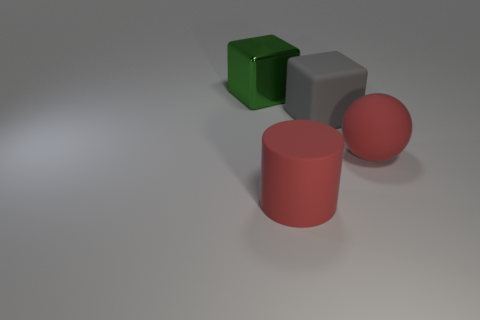Add 2 rubber balls. How many objects exist? 6 Add 2 red objects. How many red objects exist? 4 Subtract 0 yellow cylinders. How many objects are left? 4 Subtract all cylinders. How many objects are left? 3 Subtract all gray cubes. Subtract all red balls. How many cubes are left? 1 Subtract all green shiny cubes. Subtract all large shiny things. How many objects are left? 2 Add 1 large rubber blocks. How many large rubber blocks are left? 2 